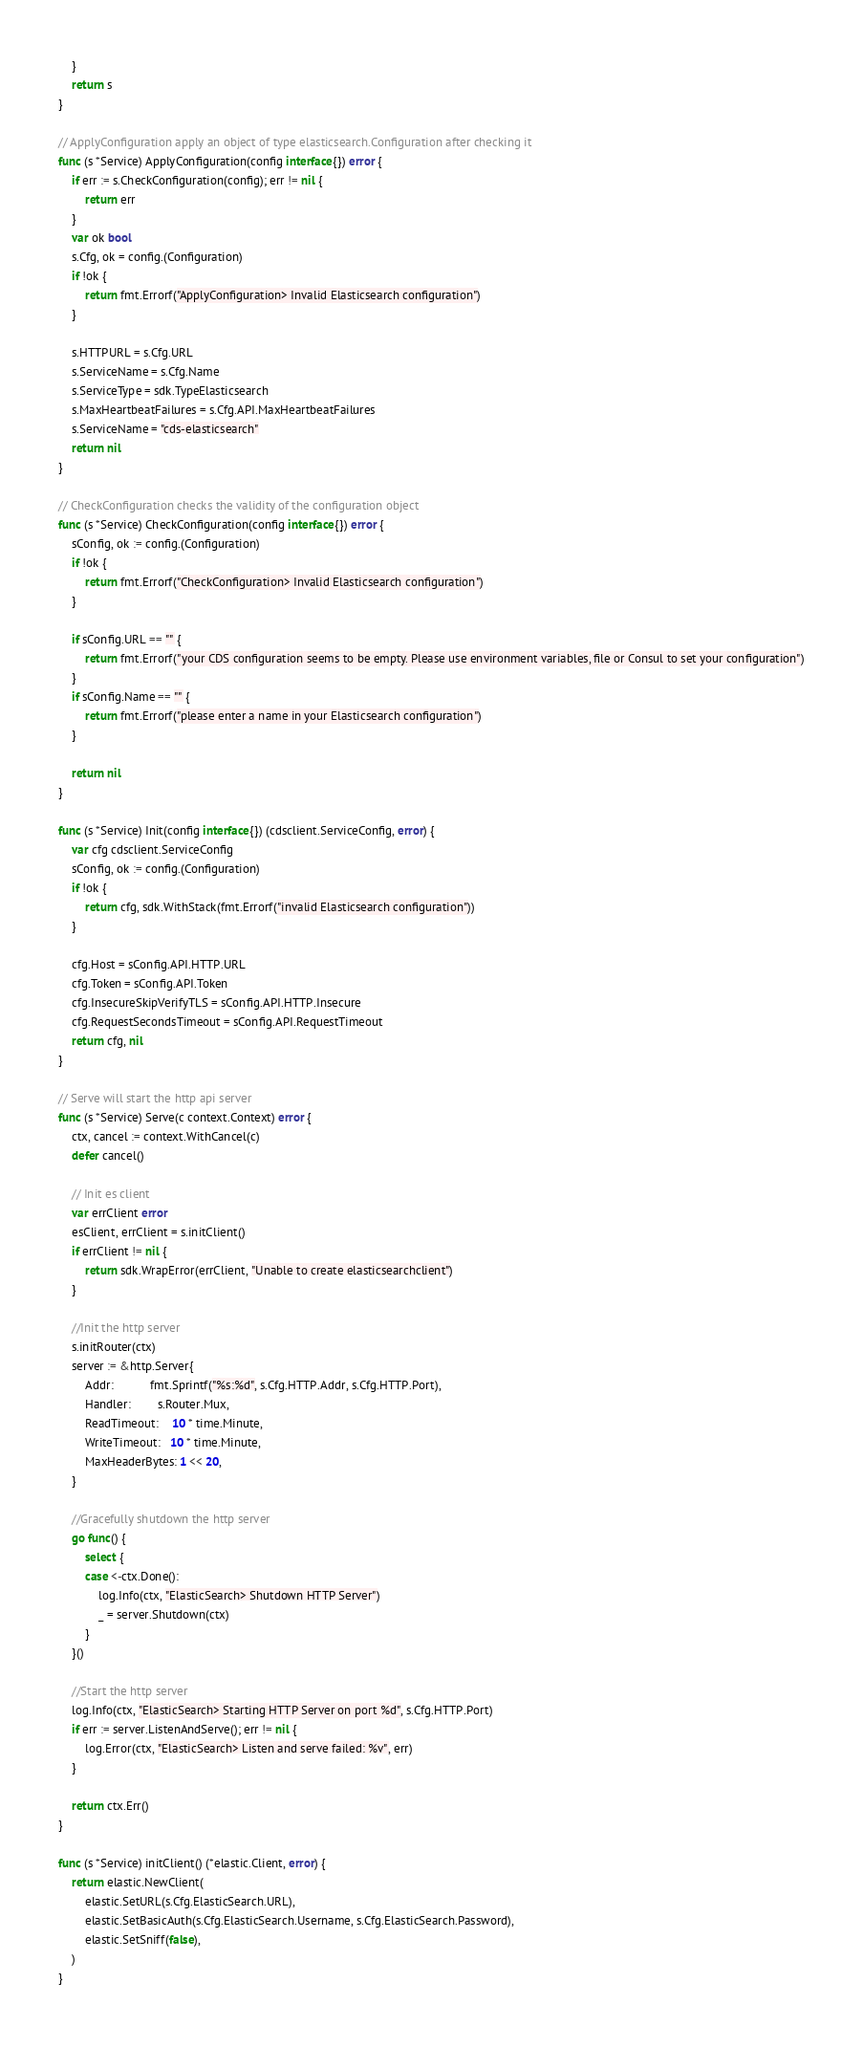Convert code to text. <code><loc_0><loc_0><loc_500><loc_500><_Go_>	}
	return s
}

// ApplyConfiguration apply an object of type elasticsearch.Configuration after checking it
func (s *Service) ApplyConfiguration(config interface{}) error {
	if err := s.CheckConfiguration(config); err != nil {
		return err
	}
	var ok bool
	s.Cfg, ok = config.(Configuration)
	if !ok {
		return fmt.Errorf("ApplyConfiguration> Invalid Elasticsearch configuration")
	}

	s.HTTPURL = s.Cfg.URL
	s.ServiceName = s.Cfg.Name
	s.ServiceType = sdk.TypeElasticsearch
	s.MaxHeartbeatFailures = s.Cfg.API.MaxHeartbeatFailures
	s.ServiceName = "cds-elasticsearch"
	return nil
}

// CheckConfiguration checks the validity of the configuration object
func (s *Service) CheckConfiguration(config interface{}) error {
	sConfig, ok := config.(Configuration)
	if !ok {
		return fmt.Errorf("CheckConfiguration> Invalid Elasticsearch configuration")
	}

	if sConfig.URL == "" {
		return fmt.Errorf("your CDS configuration seems to be empty. Please use environment variables, file or Consul to set your configuration")
	}
	if sConfig.Name == "" {
		return fmt.Errorf("please enter a name in your Elasticsearch configuration")
	}

	return nil
}

func (s *Service) Init(config interface{}) (cdsclient.ServiceConfig, error) {
	var cfg cdsclient.ServiceConfig
	sConfig, ok := config.(Configuration)
	if !ok {
		return cfg, sdk.WithStack(fmt.Errorf("invalid Elasticsearch configuration"))
	}

	cfg.Host = sConfig.API.HTTP.URL
	cfg.Token = sConfig.API.Token
	cfg.InsecureSkipVerifyTLS = sConfig.API.HTTP.Insecure
	cfg.RequestSecondsTimeout = sConfig.API.RequestTimeout
	return cfg, nil
}

// Serve will start the http api server
func (s *Service) Serve(c context.Context) error {
	ctx, cancel := context.WithCancel(c)
	defer cancel()

	// Init es client
	var errClient error
	esClient, errClient = s.initClient()
	if errClient != nil {
		return sdk.WrapError(errClient, "Unable to create elasticsearchclient")
	}

	//Init the http server
	s.initRouter(ctx)
	server := &http.Server{
		Addr:           fmt.Sprintf("%s:%d", s.Cfg.HTTP.Addr, s.Cfg.HTTP.Port),
		Handler:        s.Router.Mux,
		ReadTimeout:    10 * time.Minute,
		WriteTimeout:   10 * time.Minute,
		MaxHeaderBytes: 1 << 20,
	}

	//Gracefully shutdown the http server
	go func() {
		select {
		case <-ctx.Done():
			log.Info(ctx, "ElasticSearch> Shutdown HTTP Server")
			_ = server.Shutdown(ctx)
		}
	}()

	//Start the http server
	log.Info(ctx, "ElasticSearch> Starting HTTP Server on port %d", s.Cfg.HTTP.Port)
	if err := server.ListenAndServe(); err != nil {
		log.Error(ctx, "ElasticSearch> Listen and serve failed: %v", err)
	}

	return ctx.Err()
}

func (s *Service) initClient() (*elastic.Client, error) {
	return elastic.NewClient(
		elastic.SetURL(s.Cfg.ElasticSearch.URL),
		elastic.SetBasicAuth(s.Cfg.ElasticSearch.Username, s.Cfg.ElasticSearch.Password),
		elastic.SetSniff(false),
	)
}
</code> 